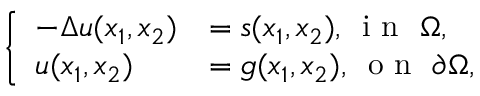Convert formula to latex. <formula><loc_0><loc_0><loc_500><loc_500>\left \{ \begin{array} { l l } { - \Delta u ( x _ { 1 } , x _ { 2 } ) } & { = s ( x _ { 1 } , x _ { 2 } ) , \, i n \, \Omega , } \\ { u ( x _ { 1 } , x _ { 2 } ) } & { = g ( x _ { 1 } , x _ { 2 } ) , \, o n \, \partial \Omega , } \end{array}</formula> 